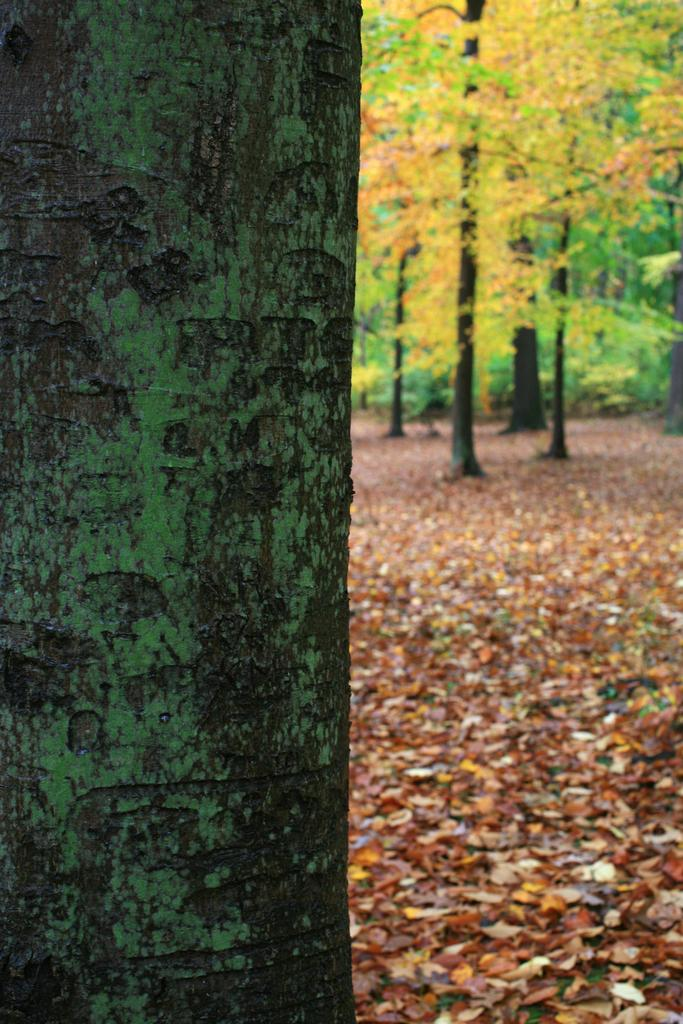What is the main subject of the image? The main subject of the image is a tree trunk. Are there any other trees visible in the image? Yes, there are trees in the image. What type of vegetation is present in the image besides trees? There is grass in the image. What type of paint is being used to decorate the tree trunk in the image? There is no paint or decoration visible on the tree trunk in the image. Can you tell me how many achievers are standing near the tree trunk in the image? There are no people or achievers present in the image; it only features a tree trunk, trees, and grass. 